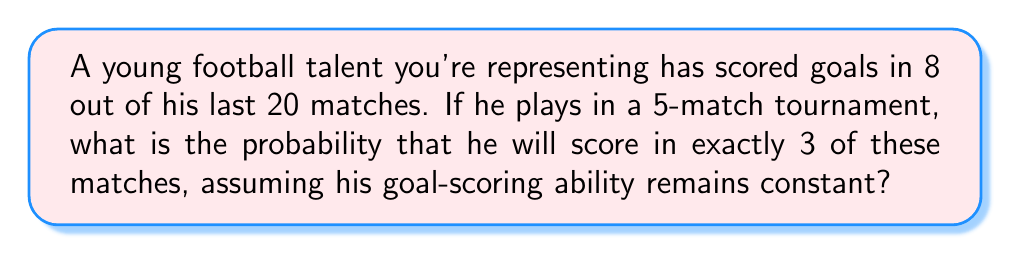Could you help me with this problem? To solve this problem, we'll use the binomial probability distribution, which is appropriate for a fixed number of independent trials with two possible outcomes (success or failure).

Step 1: Identify the components of the binomial distribution:
- $n$ = number of trials (matches) = 5
- $k$ = number of successes (matches with goals) = 3
- $p$ = probability of success (scoring in a match) = 8/20 = 0.4
- $q$ = probability of failure (not scoring) = 1 - p = 0.6

Step 2: Use the binomial probability formula:

$$P(X = k) = \binom{n}{k} p^k q^{n-k}$$

Where $\binom{n}{k}$ is the binomial coefficient, calculated as:

$$\binom{n}{k} = \frac{n!}{k!(n-k)!}$$

Step 3: Calculate the binomial coefficient:
$$\binom{5}{3} = \frac{5!}{3!(5-3)!} = \frac{5 \cdot 4 \cdot 3!}{3! \cdot 2 \cdot 1} = 10$$

Step 4: Plug all values into the binomial probability formula:

$$P(X = 3) = 10 \cdot (0.4)^3 \cdot (0.6)^{5-3}$$
$$= 10 \cdot (0.4)^3 \cdot (0.6)^2$$
$$= 10 \cdot 0.064 \cdot 0.36$$
$$= 0.2304$$

Step 5: Convert to a percentage:
0.2304 * 100 = 23.04%
Answer: 23.04% 